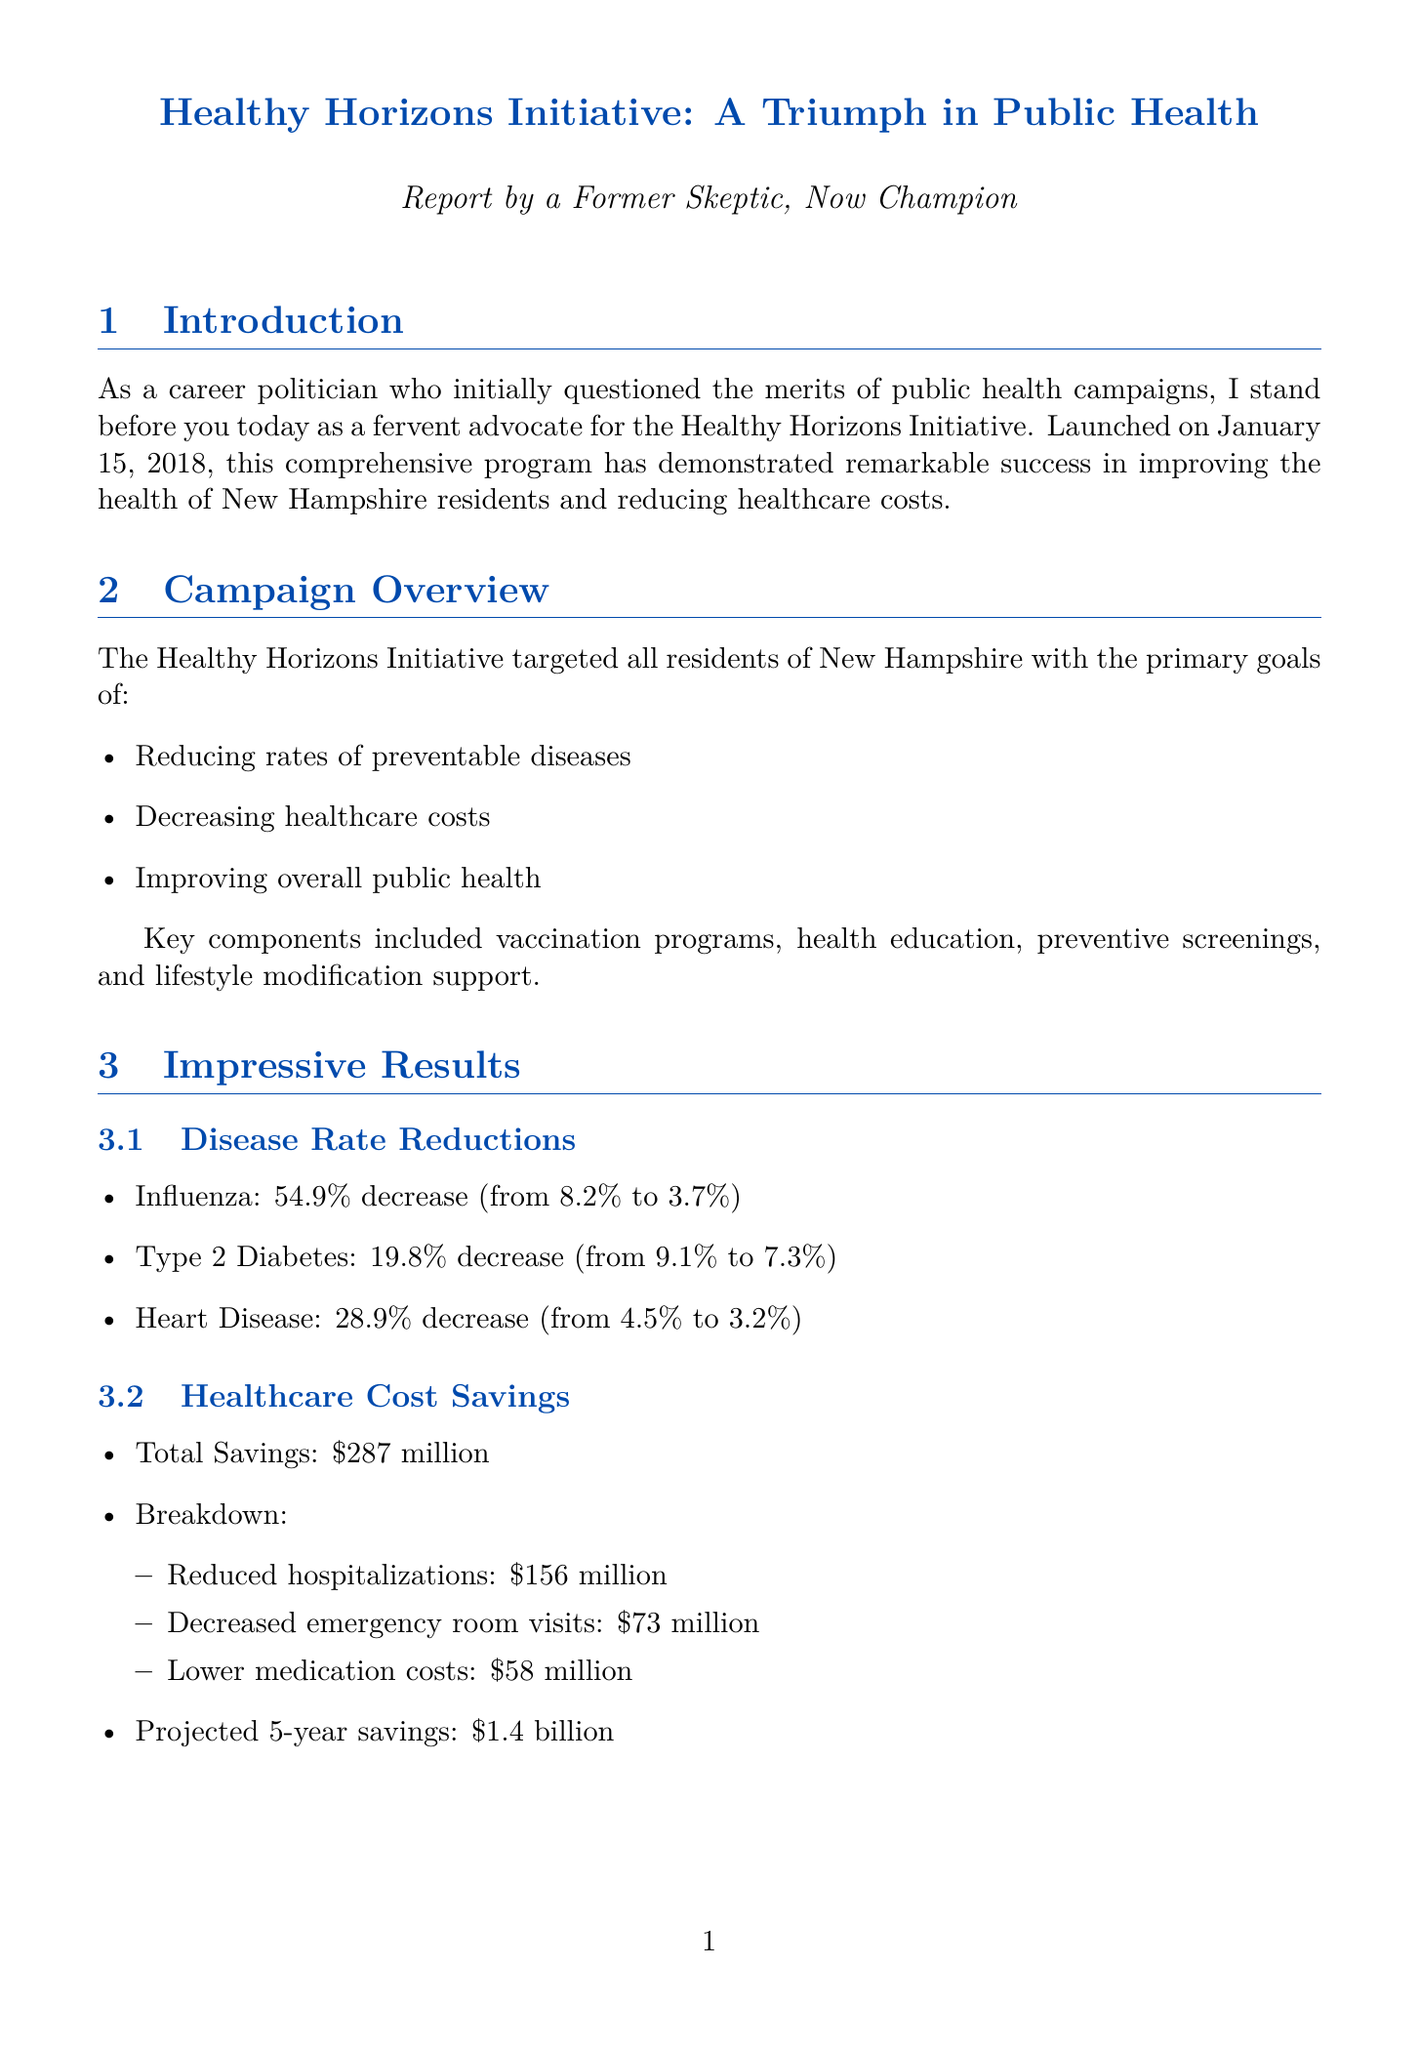What is the name of the initiative? The name of the initiative is mentioned in the campaign overview section.
Answer: Healthy Horizons Initiative When was the campaign launched? The launch date is provided in the campaign overview section.
Answer: January 15, 2018 What was the percentage decrease in influenza rates? The percentage decrease is calculated based on pre-campaign and post-campaign rates.
Answer: 54.9% How much total savings was achieved by the campaign? The total savings is detailed in the healthcare cost savings section.
Answer: $287 million What is the projected five-year savings? The projected savings over five years is specifically indicated in the healthcare cost savings section.
Answer: $1.4 billion What role did community leaders play in the campaign? Their involvement is listed as a key success factor, emphasizing their importance in the initiative.
Answer: Engagement of community leaders What was the public approval rating for the initiative? The public approval rating is found in the political impact section of the document.
Answer: 76% How many new positions were created due to the initiative? The number of new positions created is noted in the economic impact section.
Answer: 1,200 What is one of the future plans mentioned? The future plans are listed at the end of the document, indicating the initiative's direction.
Answer: Expand mental health services 